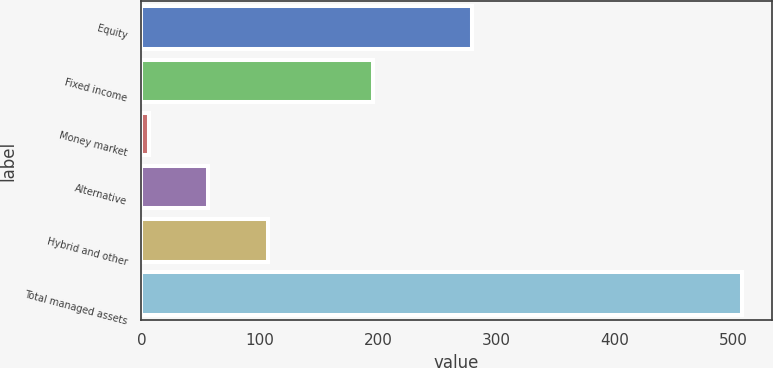Convert chart to OTSL. <chart><loc_0><loc_0><loc_500><loc_500><bar_chart><fcel>Equity<fcel>Fixed income<fcel>Money market<fcel>Alternative<fcel>Hybrid and other<fcel>Total managed assets<nl><fcel>279.4<fcel>195.9<fcel>6.6<fcel>56.67<fcel>106.74<fcel>507.3<nl></chart> 